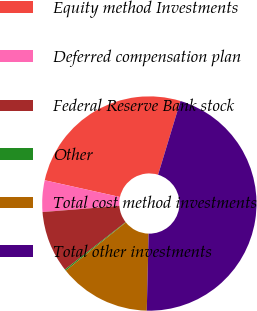Convert chart to OTSL. <chart><loc_0><loc_0><loc_500><loc_500><pie_chart><fcel>Equity method Investments<fcel>Deferred compensation plan<fcel>Federal Reserve Bank stock<fcel>Other<fcel>Total cost method investments<fcel>Total other investments<nl><fcel>26.21%<fcel>4.75%<fcel>9.3%<fcel>0.2%<fcel>13.85%<fcel>45.69%<nl></chart> 